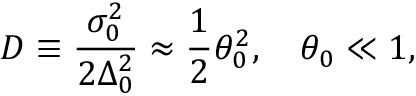<formula> <loc_0><loc_0><loc_500><loc_500>D \equiv \frac { \sigma _ { 0 } ^ { 2 } } { 2 \Delta _ { 0 } ^ { 2 } } \approx \frac { 1 } { 2 } \theta _ { 0 } ^ { 2 } , \quad \theta _ { 0 } \ll 1 ,</formula> 